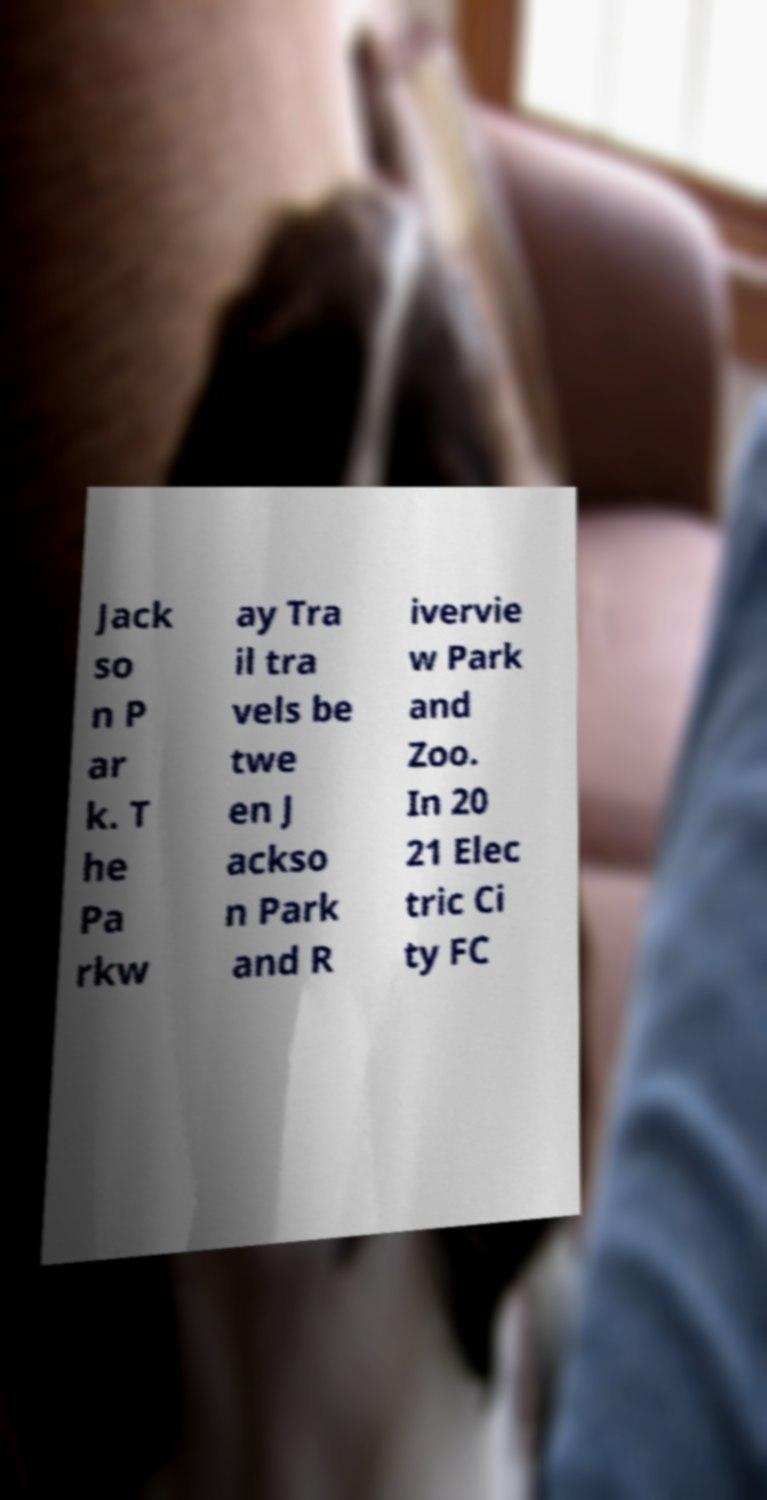Could you assist in decoding the text presented in this image and type it out clearly? Jack so n P ar k. T he Pa rkw ay Tra il tra vels be twe en J ackso n Park and R ivervie w Park and Zoo. In 20 21 Elec tric Ci ty FC 